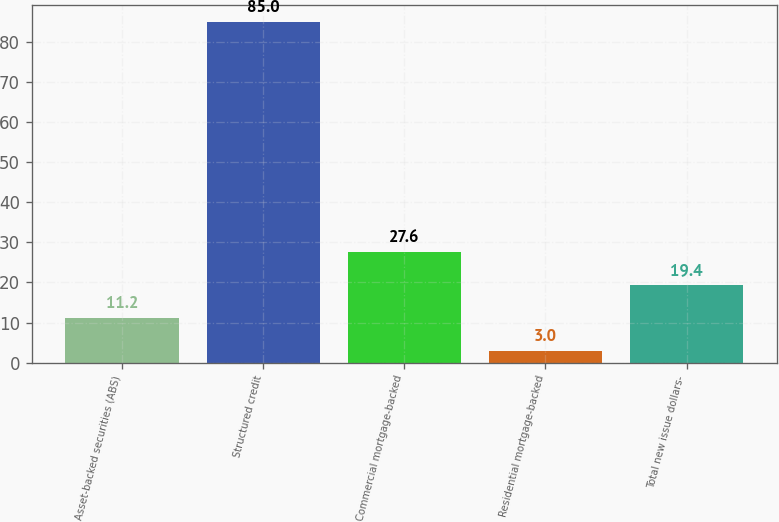Convert chart. <chart><loc_0><loc_0><loc_500><loc_500><bar_chart><fcel>Asset-backed securities (ABS)<fcel>Structured credit<fcel>Commercial mortgage-backed<fcel>Residential mortgage-backed<fcel>Total new issue dollars-<nl><fcel>11.2<fcel>85<fcel>27.6<fcel>3<fcel>19.4<nl></chart> 